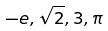Convert formula to latex. <formula><loc_0><loc_0><loc_500><loc_500>- e , \sqrt { 2 } , 3 , \pi</formula> 